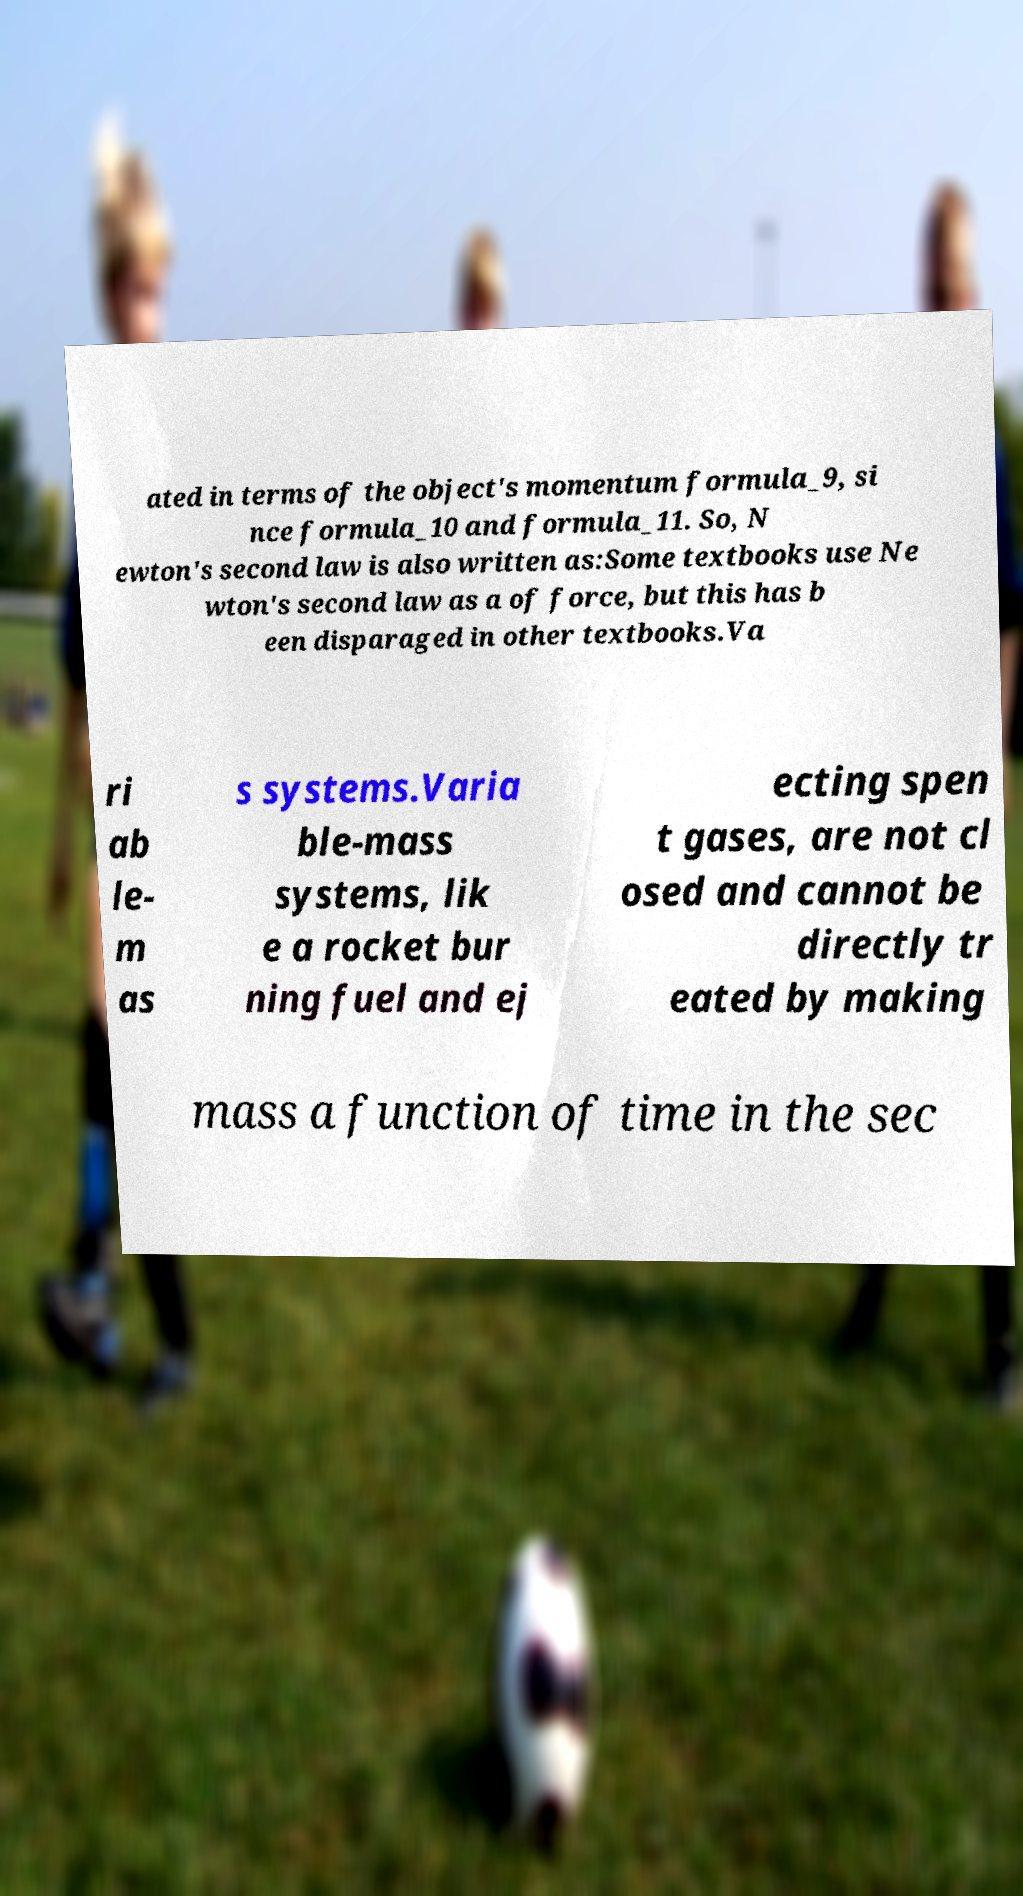There's text embedded in this image that I need extracted. Can you transcribe it verbatim? ated in terms of the object's momentum formula_9, si nce formula_10 and formula_11. So, N ewton's second law is also written as:Some textbooks use Ne wton's second law as a of force, but this has b een disparaged in other textbooks.Va ri ab le- m as s systems.Varia ble-mass systems, lik e a rocket bur ning fuel and ej ecting spen t gases, are not cl osed and cannot be directly tr eated by making mass a function of time in the sec 